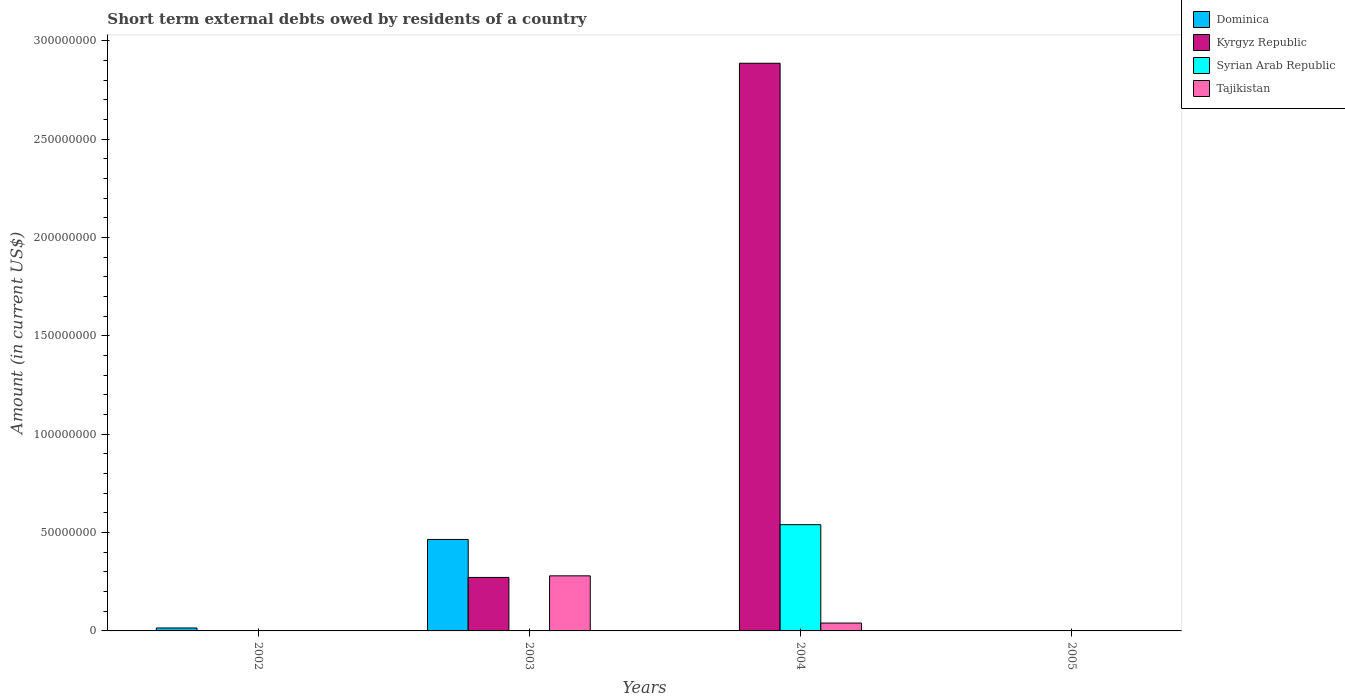Are the number of bars on each tick of the X-axis equal?
Offer a very short reply. No. How many bars are there on the 4th tick from the left?
Offer a terse response. 0. How many bars are there on the 4th tick from the right?
Ensure brevity in your answer.  1. What is the label of the 4th group of bars from the left?
Your answer should be compact. 2005. In how many cases, is the number of bars for a given year not equal to the number of legend labels?
Ensure brevity in your answer.  4. What is the amount of short-term external debts owed by residents in Dominica in 2002?
Provide a short and direct response. 1.50e+06. Across all years, what is the maximum amount of short-term external debts owed by residents in Dominica?
Keep it short and to the point. 4.65e+07. Across all years, what is the minimum amount of short-term external debts owed by residents in Tajikistan?
Keep it short and to the point. 0. What is the total amount of short-term external debts owed by residents in Tajikistan in the graph?
Provide a succinct answer. 3.20e+07. What is the difference between the amount of short-term external debts owed by residents in Kyrgyz Republic in 2003 and that in 2004?
Provide a short and direct response. -2.61e+08. What is the difference between the amount of short-term external debts owed by residents in Kyrgyz Republic in 2003 and the amount of short-term external debts owed by residents in Tajikistan in 2002?
Your answer should be compact. 2.72e+07. What is the average amount of short-term external debts owed by residents in Dominica per year?
Provide a succinct answer. 1.20e+07. In the year 2004, what is the difference between the amount of short-term external debts owed by residents in Syrian Arab Republic and amount of short-term external debts owed by residents in Tajikistan?
Ensure brevity in your answer.  5.00e+07. In how many years, is the amount of short-term external debts owed by residents in Syrian Arab Republic greater than 250000000 US$?
Provide a succinct answer. 0. What is the difference between the highest and the lowest amount of short-term external debts owed by residents in Tajikistan?
Give a very brief answer. 2.80e+07. In how many years, is the amount of short-term external debts owed by residents in Tajikistan greater than the average amount of short-term external debts owed by residents in Tajikistan taken over all years?
Your response must be concise. 1. Is it the case that in every year, the sum of the amount of short-term external debts owed by residents in Syrian Arab Republic and amount of short-term external debts owed by residents in Dominica is greater than the sum of amount of short-term external debts owed by residents in Kyrgyz Republic and amount of short-term external debts owed by residents in Tajikistan?
Give a very brief answer. No. How many bars are there?
Ensure brevity in your answer.  7. Are all the bars in the graph horizontal?
Offer a terse response. No. Are the values on the major ticks of Y-axis written in scientific E-notation?
Make the answer very short. No. Does the graph contain any zero values?
Provide a short and direct response. Yes. Does the graph contain grids?
Make the answer very short. No. Where does the legend appear in the graph?
Your answer should be compact. Top right. How many legend labels are there?
Your response must be concise. 4. How are the legend labels stacked?
Give a very brief answer. Vertical. What is the title of the graph?
Offer a very short reply. Short term external debts owed by residents of a country. What is the label or title of the Y-axis?
Provide a succinct answer. Amount (in current US$). What is the Amount (in current US$) in Dominica in 2002?
Your answer should be very brief. 1.50e+06. What is the Amount (in current US$) of Kyrgyz Republic in 2002?
Provide a succinct answer. 0. What is the Amount (in current US$) of Dominica in 2003?
Your answer should be very brief. 4.65e+07. What is the Amount (in current US$) of Kyrgyz Republic in 2003?
Give a very brief answer. 2.72e+07. What is the Amount (in current US$) in Tajikistan in 2003?
Offer a terse response. 2.80e+07. What is the Amount (in current US$) of Kyrgyz Republic in 2004?
Keep it short and to the point. 2.89e+08. What is the Amount (in current US$) of Syrian Arab Republic in 2004?
Give a very brief answer. 5.40e+07. What is the Amount (in current US$) in Tajikistan in 2004?
Provide a short and direct response. 4.00e+06. What is the Amount (in current US$) in Dominica in 2005?
Give a very brief answer. 0. What is the Amount (in current US$) in Syrian Arab Republic in 2005?
Ensure brevity in your answer.  0. Across all years, what is the maximum Amount (in current US$) of Dominica?
Give a very brief answer. 4.65e+07. Across all years, what is the maximum Amount (in current US$) of Kyrgyz Republic?
Keep it short and to the point. 2.89e+08. Across all years, what is the maximum Amount (in current US$) of Syrian Arab Republic?
Offer a very short reply. 5.40e+07. Across all years, what is the maximum Amount (in current US$) of Tajikistan?
Offer a very short reply. 2.80e+07. Across all years, what is the minimum Amount (in current US$) of Dominica?
Your response must be concise. 0. Across all years, what is the minimum Amount (in current US$) in Syrian Arab Republic?
Make the answer very short. 0. What is the total Amount (in current US$) in Dominica in the graph?
Your answer should be compact. 4.80e+07. What is the total Amount (in current US$) of Kyrgyz Republic in the graph?
Ensure brevity in your answer.  3.16e+08. What is the total Amount (in current US$) of Syrian Arab Republic in the graph?
Offer a terse response. 5.40e+07. What is the total Amount (in current US$) in Tajikistan in the graph?
Give a very brief answer. 3.20e+07. What is the difference between the Amount (in current US$) in Dominica in 2002 and that in 2003?
Your answer should be very brief. -4.50e+07. What is the difference between the Amount (in current US$) in Kyrgyz Republic in 2003 and that in 2004?
Provide a succinct answer. -2.61e+08. What is the difference between the Amount (in current US$) in Tajikistan in 2003 and that in 2004?
Your answer should be very brief. 2.40e+07. What is the difference between the Amount (in current US$) of Dominica in 2002 and the Amount (in current US$) of Kyrgyz Republic in 2003?
Provide a succinct answer. -2.57e+07. What is the difference between the Amount (in current US$) in Dominica in 2002 and the Amount (in current US$) in Tajikistan in 2003?
Provide a short and direct response. -2.65e+07. What is the difference between the Amount (in current US$) in Dominica in 2002 and the Amount (in current US$) in Kyrgyz Republic in 2004?
Offer a very short reply. -2.87e+08. What is the difference between the Amount (in current US$) in Dominica in 2002 and the Amount (in current US$) in Syrian Arab Republic in 2004?
Your response must be concise. -5.25e+07. What is the difference between the Amount (in current US$) of Dominica in 2002 and the Amount (in current US$) of Tajikistan in 2004?
Offer a terse response. -2.50e+06. What is the difference between the Amount (in current US$) in Dominica in 2003 and the Amount (in current US$) in Kyrgyz Republic in 2004?
Offer a very short reply. -2.42e+08. What is the difference between the Amount (in current US$) in Dominica in 2003 and the Amount (in current US$) in Syrian Arab Republic in 2004?
Make the answer very short. -7.50e+06. What is the difference between the Amount (in current US$) in Dominica in 2003 and the Amount (in current US$) in Tajikistan in 2004?
Your answer should be compact. 4.25e+07. What is the difference between the Amount (in current US$) in Kyrgyz Republic in 2003 and the Amount (in current US$) in Syrian Arab Republic in 2004?
Offer a terse response. -2.68e+07. What is the difference between the Amount (in current US$) in Kyrgyz Republic in 2003 and the Amount (in current US$) in Tajikistan in 2004?
Keep it short and to the point. 2.32e+07. What is the average Amount (in current US$) in Kyrgyz Republic per year?
Provide a succinct answer. 7.89e+07. What is the average Amount (in current US$) of Syrian Arab Republic per year?
Give a very brief answer. 1.35e+07. In the year 2003, what is the difference between the Amount (in current US$) in Dominica and Amount (in current US$) in Kyrgyz Republic?
Provide a succinct answer. 1.93e+07. In the year 2003, what is the difference between the Amount (in current US$) of Dominica and Amount (in current US$) of Tajikistan?
Make the answer very short. 1.85e+07. In the year 2003, what is the difference between the Amount (in current US$) of Kyrgyz Republic and Amount (in current US$) of Tajikistan?
Keep it short and to the point. -8.10e+05. In the year 2004, what is the difference between the Amount (in current US$) of Kyrgyz Republic and Amount (in current US$) of Syrian Arab Republic?
Ensure brevity in your answer.  2.35e+08. In the year 2004, what is the difference between the Amount (in current US$) of Kyrgyz Republic and Amount (in current US$) of Tajikistan?
Your answer should be very brief. 2.85e+08. In the year 2004, what is the difference between the Amount (in current US$) of Syrian Arab Republic and Amount (in current US$) of Tajikistan?
Provide a succinct answer. 5.00e+07. What is the ratio of the Amount (in current US$) of Dominica in 2002 to that in 2003?
Keep it short and to the point. 0.03. What is the ratio of the Amount (in current US$) of Kyrgyz Republic in 2003 to that in 2004?
Ensure brevity in your answer.  0.09. What is the ratio of the Amount (in current US$) of Tajikistan in 2003 to that in 2004?
Your response must be concise. 7. What is the difference between the highest and the lowest Amount (in current US$) in Dominica?
Offer a terse response. 4.65e+07. What is the difference between the highest and the lowest Amount (in current US$) in Kyrgyz Republic?
Give a very brief answer. 2.89e+08. What is the difference between the highest and the lowest Amount (in current US$) in Syrian Arab Republic?
Provide a short and direct response. 5.40e+07. What is the difference between the highest and the lowest Amount (in current US$) in Tajikistan?
Provide a succinct answer. 2.80e+07. 